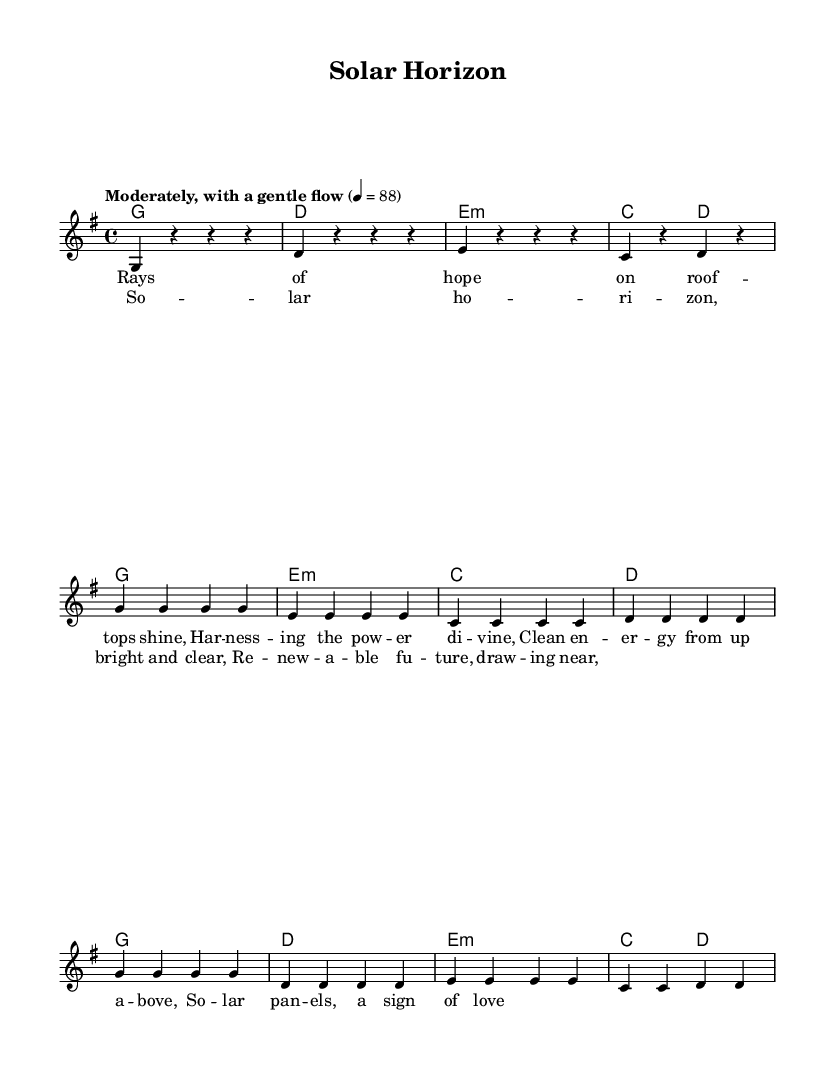What is the key signature of this music? The key signature is G major, which has one sharp (F#). This can be identified from the marked key at the beginning of the score.
Answer: G major What is the time signature of this music? The time signature is 4/4, as indicated at the beginning of the score. This means there are four beats in each measure and the quarter note gets one beat.
Answer: 4/4 What is the tempo marking for this music? The tempo marking is "Moderately, with a gentle flow" followed by the metronome mark of 4 = 88, indicating the speed at which the piece should be played.
Answer: Moderately, with a gentle flow How many measures are in the chorus section? The chorus is composed of four measures, which can be counted by observing the notations for the chorus lines in the score.
Answer: 4 Which chord is used at the beginning of this piece? The first chord shown is G, which appears in the intro section of the score, symbolizing the harmonic foundation for the piece.
Answer: G What type of energy theme is explored in this song? The theme explored is solar energy and renewable energy, as indicated by the lyrics and the title of the song "Solar Horizon".
Answer: Solar energy How does the melody of the chorus compare to the verse? The melody of the chorus repeats the pattern of pitches seen in the verse but with different lyrics, showcasing how the song structure maintains thematic continuity.
Answer: Similar pattern 